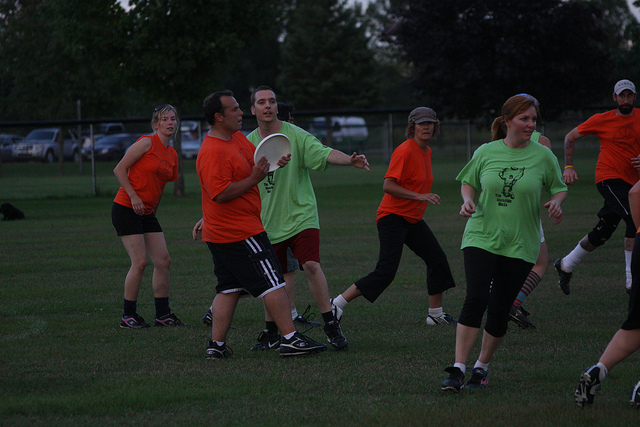<image>What is the ethnicity of the woman wearing the green shirt with the black hair? I am not sure about the ethnicity of the woman wearing the green shirt with the black hair. She might be Caucasian or European. What is the ethnicity of the woman wearing the green shirt with the black hair? I am not sure about the ethnicity of the woman wearing the green shirt with black hair. It can be seen as caucasian or white. 